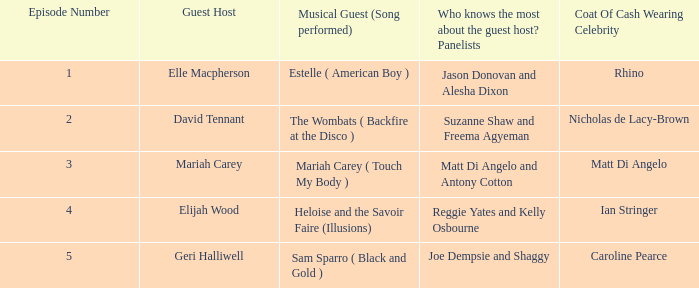Help me parse the entirety of this table. {'header': ['Episode Number', 'Guest Host', 'Musical Guest (Song performed)', 'Who knows the most about the guest host? Panelists', 'Coat Of Cash Wearing Celebrity'], 'rows': [['1', 'Elle Macpherson', 'Estelle ( American Boy )', 'Jason Donovan and Alesha Dixon', 'Rhino'], ['2', 'David Tennant', 'The Wombats ( Backfire at the Disco )', 'Suzanne Shaw and Freema Agyeman', 'Nicholas de Lacy-Brown'], ['3', 'Mariah Carey', 'Mariah Carey ( Touch My Body )', 'Matt Di Angelo and Antony Cotton', 'Matt Di Angelo'], ['4', 'Elijah Wood', 'Heloise and the Savoir Faire (Illusions)', 'Reggie Yates and Kelly Osbourne', 'Ian Stringer'], ['5', 'Geri Halliwell', 'Sam Sparro ( Black and Gold )', 'Joe Dempsie and Shaggy', 'Caroline Pearce']]} Name the total number of episodes for coat of cash wearing celebrity is matt di angelo 1.0. 